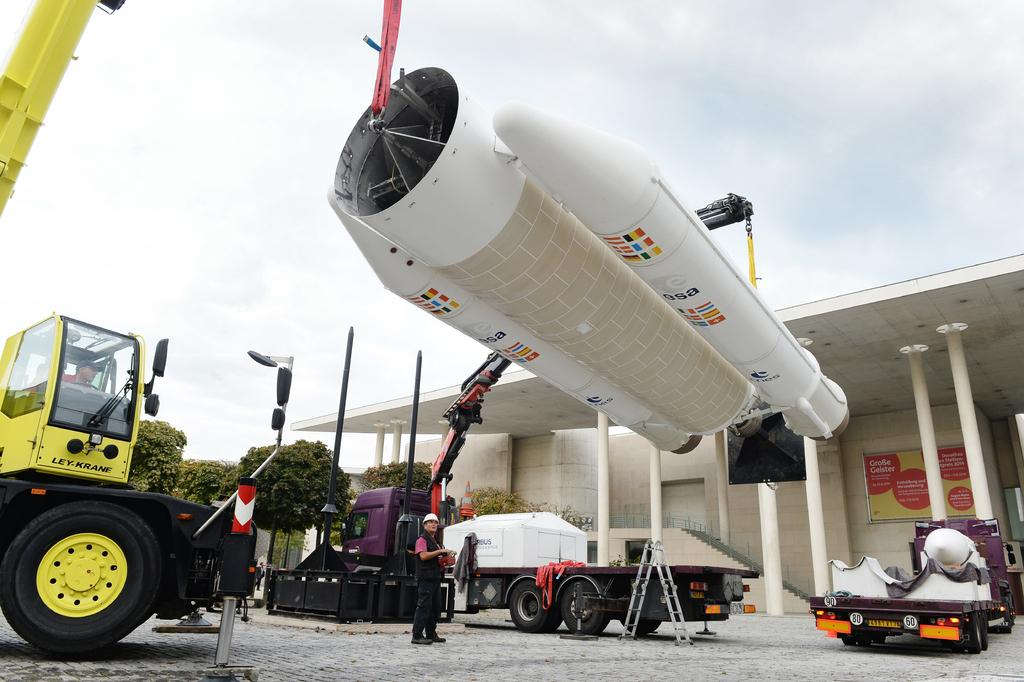What types of vehicles can be seen in the image? There are motor vehicles in the image. What other objects related to transportation are present in the image? There are spare parts of an aircraft in the image. Can you describe the setting in which the vehicles and aircraft parts are located? There is a building and trees in the image, as well as an advertisement board. Is there any indication of the weather in the image? Yes, the sky is visible in the image, and there are clouds present. Can you describe the person in the image? There is a person standing on the floor in the image. Where is the baby sitting in the image? There is no baby present in the image. What type of note is attached to the advertisement board in the image? There is no note attached to the advertisement board in the image. 